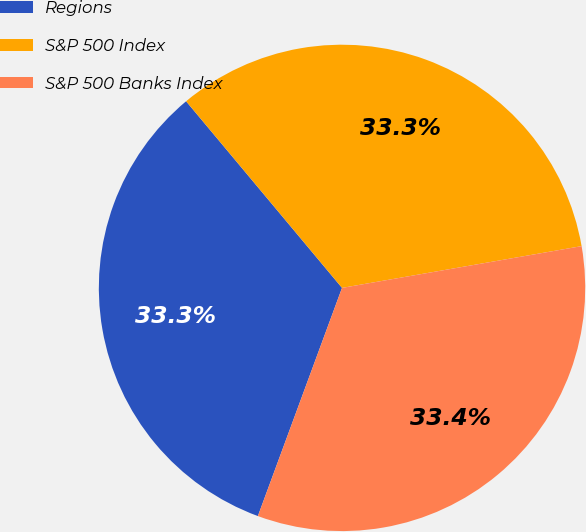<chart> <loc_0><loc_0><loc_500><loc_500><pie_chart><fcel>Regions<fcel>S&P 500 Index<fcel>S&P 500 Banks Index<nl><fcel>33.3%<fcel>33.33%<fcel>33.37%<nl></chart> 